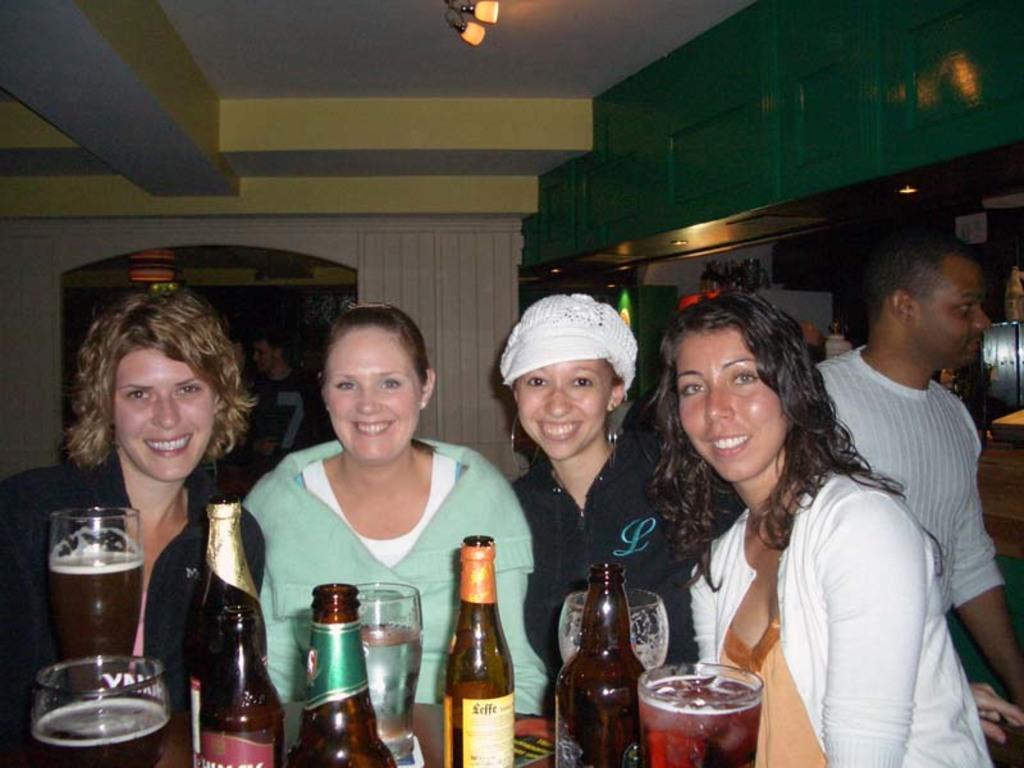Describe this image in one or two sentences. In this picture we can see four persons standing on the floor. They are smiling. This is table. On the table there are glasses, and bottles. Here we can see a man. On the background there is a wall and this is light. 